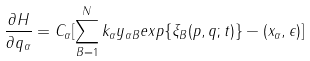<formula> <loc_0><loc_0><loc_500><loc_500>\frac { \partial H } { \partial q _ { \alpha } } = C _ { \alpha } [ \sum _ { B = 1 } ^ { N } k _ { \alpha } y _ { \alpha B } e x p \{ \xi _ { B } ( p , q ; t ) \} - ( x _ { \alpha } , \epsilon ) ]</formula> 